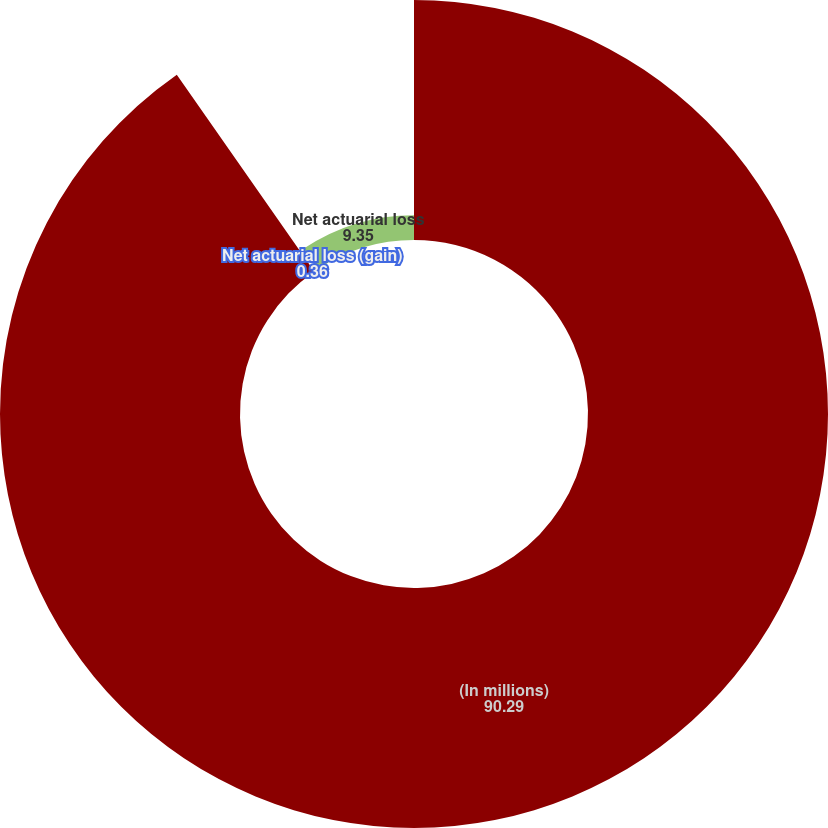<chart> <loc_0><loc_0><loc_500><loc_500><pie_chart><fcel>(In millions)<fcel>Net actuarial loss (gain)<fcel>Net actuarial loss<nl><fcel>90.29%<fcel>0.36%<fcel>9.35%<nl></chart> 